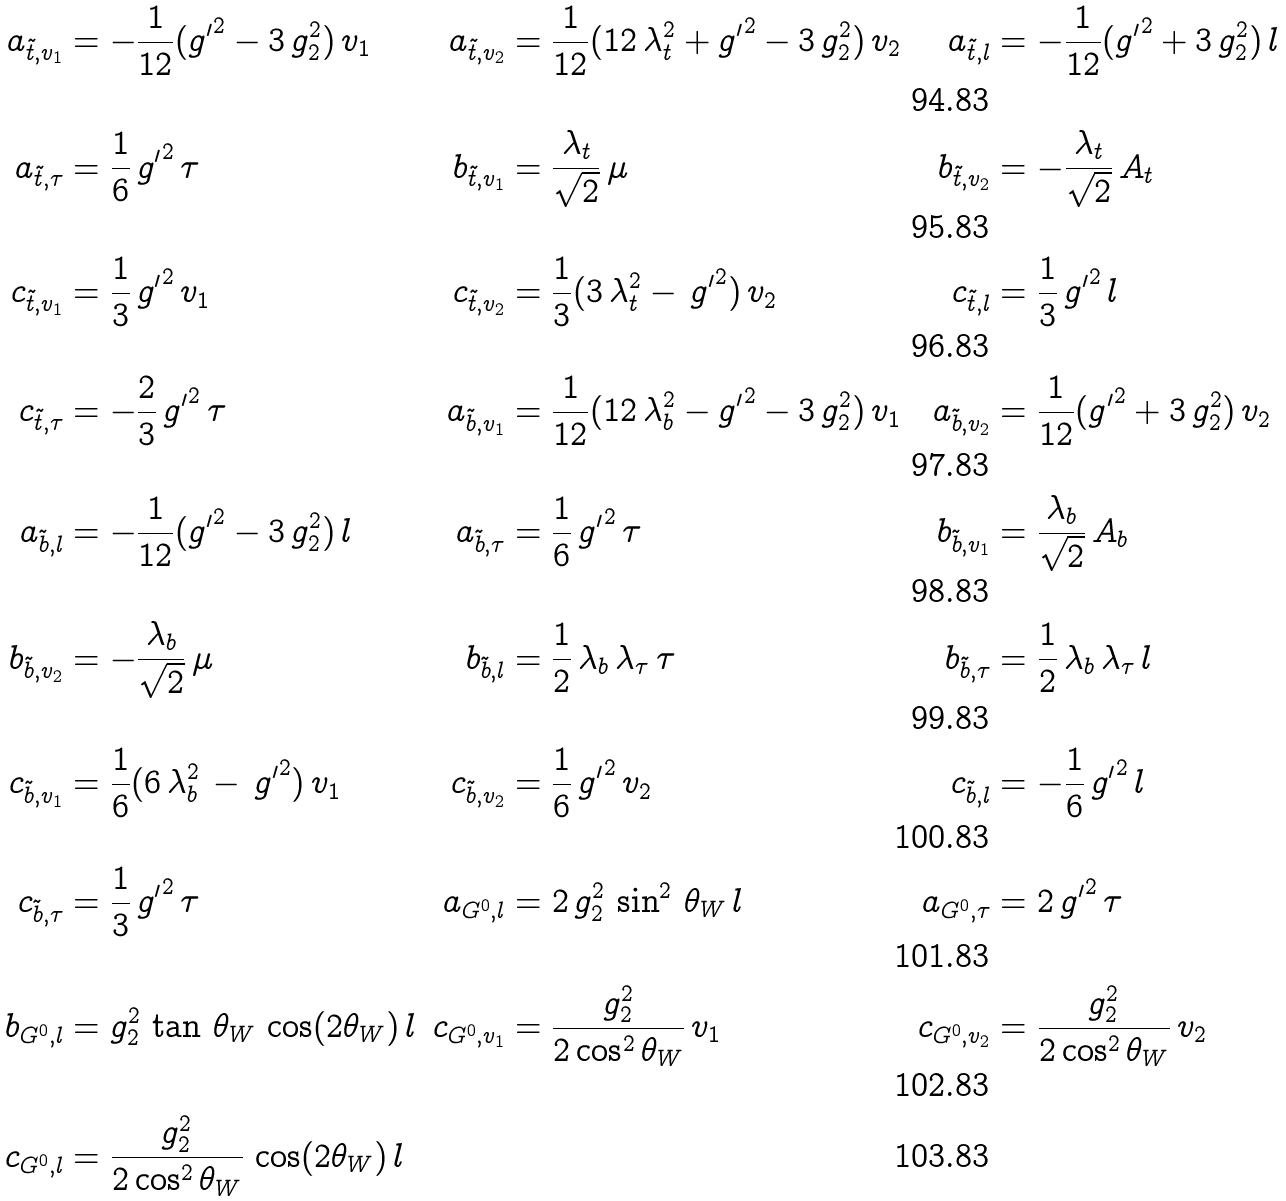Convert formula to latex. <formula><loc_0><loc_0><loc_500><loc_500>a _ { \tilde { t } , v _ { 1 } } & = - \frac { 1 } { 1 2 } ( { g ^ { \prime } } ^ { 2 } - 3 \, g _ { 2 } ^ { 2 } ) \, v _ { 1 } & a _ { \tilde { t } , v _ { 2 } } & = \frac { 1 } { 1 2 } ( 1 2 \, \lambda _ { t } ^ { 2 } + { g ^ { \prime } } ^ { 2 } - 3 \, g _ { 2 } ^ { 2 } ) \, v _ { 2 } & a _ { \tilde { t } , l } & = - \frac { 1 } { 1 2 } ( { g ^ { \prime } } ^ { 2 } + 3 \, g _ { 2 } ^ { 2 } ) \, l \\ a _ { \tilde { t } , \tau } & = \frac { 1 } { 6 } \, { g ^ { \prime } } ^ { 2 } \, \tau & b _ { \tilde { t } , v _ { 1 } } & = \frac { \lambda _ { t } } { \sqrt { 2 } } \, \mu & b _ { \tilde { t } , v _ { 2 } } & = - \frac { \lambda _ { t } } { \sqrt { 2 } } \, A _ { t } \\ c _ { \tilde { t } , v _ { 1 } } & = \frac { 1 } { 3 } \, { g ^ { \prime } } ^ { 2 } \, v _ { 1 } & c _ { \tilde { t } , v _ { 2 } } & = \frac { 1 } { 3 } ( 3 \, \lambda _ { t } ^ { 2 } - \, { g ^ { \prime } } ^ { 2 } ) \, v _ { 2 } & c _ { \tilde { t } , l } & = \frac { 1 } { 3 } \, { g ^ { \prime } } ^ { 2 } \, l \\ c _ { \tilde { t } , \tau } & = - \frac { 2 } { 3 } \, { g ^ { \prime } } ^ { 2 } \, \tau & a _ { \tilde { b } , v _ { 1 } } & = \frac { 1 } { 1 2 } ( 1 2 \, \lambda _ { b } ^ { 2 } - { g ^ { \prime } } ^ { 2 } - 3 \, g _ { 2 } ^ { 2 } ) \, v _ { 1 } & a _ { \tilde { b } , v _ { 2 } } & = \frac { 1 } { 1 2 } ( { g ^ { \prime } } ^ { 2 } + 3 \, g _ { 2 } ^ { 2 } ) \, v _ { 2 } \\ a _ { \tilde { b } , l } & = - \frac { 1 } { 1 2 } ( { g ^ { \prime } } ^ { 2 } - 3 \, g _ { 2 } ^ { 2 } ) \, l & a _ { \tilde { b } , \tau } & = \frac { 1 } { 6 } \, { g ^ { \prime } } ^ { 2 } \, \tau & b _ { \tilde { b } , v _ { 1 } } & = \frac { \lambda _ { b } } { \sqrt { 2 } } \, A _ { b } \\ b _ { \tilde { b } , v _ { 2 } } & = - \frac { \lambda _ { b } } { \sqrt { 2 } } \, \mu & b _ { \tilde { b } , l } & = \frac { 1 } { 2 } \, \lambda _ { b } \, \lambda _ { \tau } \, \tau & b _ { \tilde { b } , \tau } & = \frac { 1 } { 2 } \, \lambda _ { b } \, \lambda _ { \tau } \, l \\ c _ { \tilde { b } , v _ { 1 } } & = \frac { 1 } { 6 } ( 6 \, \lambda _ { b } ^ { 2 } \, - \, { g ^ { \prime } } ^ { 2 } ) \, v _ { 1 } & c _ { \tilde { b } , v _ { 2 } } & = \frac { 1 } { 6 } \, { g ^ { \prime } } ^ { 2 } \, v _ { 2 } & c _ { \tilde { b } , l } & = - \frac { 1 } { 6 } \, { g ^ { \prime } } ^ { 2 } \, l \\ c _ { \tilde { b } , \tau } & = \frac { 1 } { 3 } \, { g ^ { \prime } } ^ { 2 } \, \tau & a _ { G ^ { 0 } , l } & = 2 \, g _ { 2 } ^ { 2 } \, \sin ^ { 2 } \, \theta _ { W } \, l & a _ { G ^ { 0 } , \tau } & = 2 \, { g ^ { \prime } } ^ { 2 } \, \tau \\ b _ { G ^ { 0 } , l } & = g _ { 2 } ^ { 2 } \, \tan \, \theta _ { W } \, \cos ( 2 \theta _ { W } ) \, l & c _ { G ^ { 0 } , v _ { 1 } } & = \frac { g _ { 2 } ^ { 2 } } { 2 \cos ^ { 2 } \theta _ { W } } \, v _ { 1 } & c _ { G ^ { 0 } , v _ { 2 } } & = \frac { g _ { 2 } ^ { 2 } } { 2 \cos ^ { 2 } \theta _ { W } } \, v _ { 2 } \\ c _ { G ^ { 0 } , l } & = \frac { g _ { 2 } ^ { 2 } } { 2 \cos ^ { 2 } \theta _ { W } } \, \cos ( 2 \theta _ { W } ) \, l & & & &</formula> 